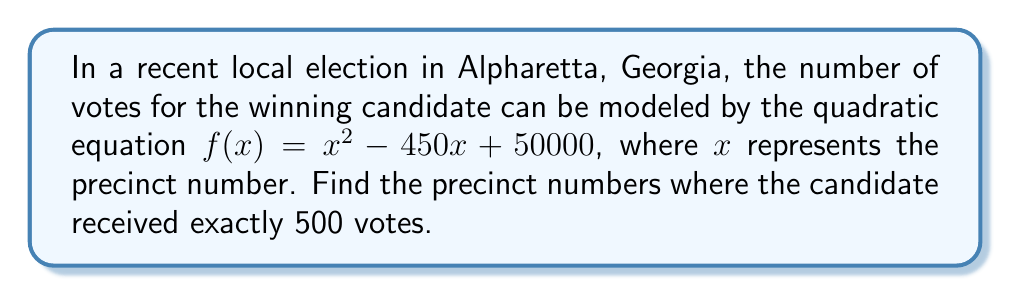Could you help me with this problem? To solve this problem, we need to find the roots of the equation $f(x) = 500$. Let's approach this step-by-step:

1) First, we set up the equation:
   $x^2 - 450x + 50000 = 500$

2) Subtract 500 from both sides to get the standard form of a quadratic equation:
   $x^2 - 450x + 49500 = 0$

3) Now we have a quadratic equation in the form $ax^2 + bx + c = 0$, where:
   $a = 1$
   $b = -450$
   $c = 49500$

4) We can solve this using the quadratic formula: $x = \frac{-b \pm \sqrt{b^2 - 4ac}}{2a}$

5) Let's substitute our values:
   $x = \frac{450 \pm \sqrt{(-450)^2 - 4(1)(49500)}}{2(1)}$

6) Simplify under the square root:
   $x = \frac{450 \pm \sqrt{202500 - 198000}}{2}$
   $x = \frac{450 \pm \sqrt{4500}}{2}$

7) Simplify further:
   $x = \frac{450 \pm 67.08203932499369}{2}$

8) This gives us two solutions:
   $x_1 = \frac{450 + 67.08203932499369}{2} = 258.5410196624968$
   $x_2 = \frac{450 - 67.08203932499369}{2} = 191.4589803375032$

9) Since precinct numbers must be integers, we round these to the nearest whole numbers:
   Precinct 259 and Precinct 191
Answer: Precinct 259 and Precinct 191 